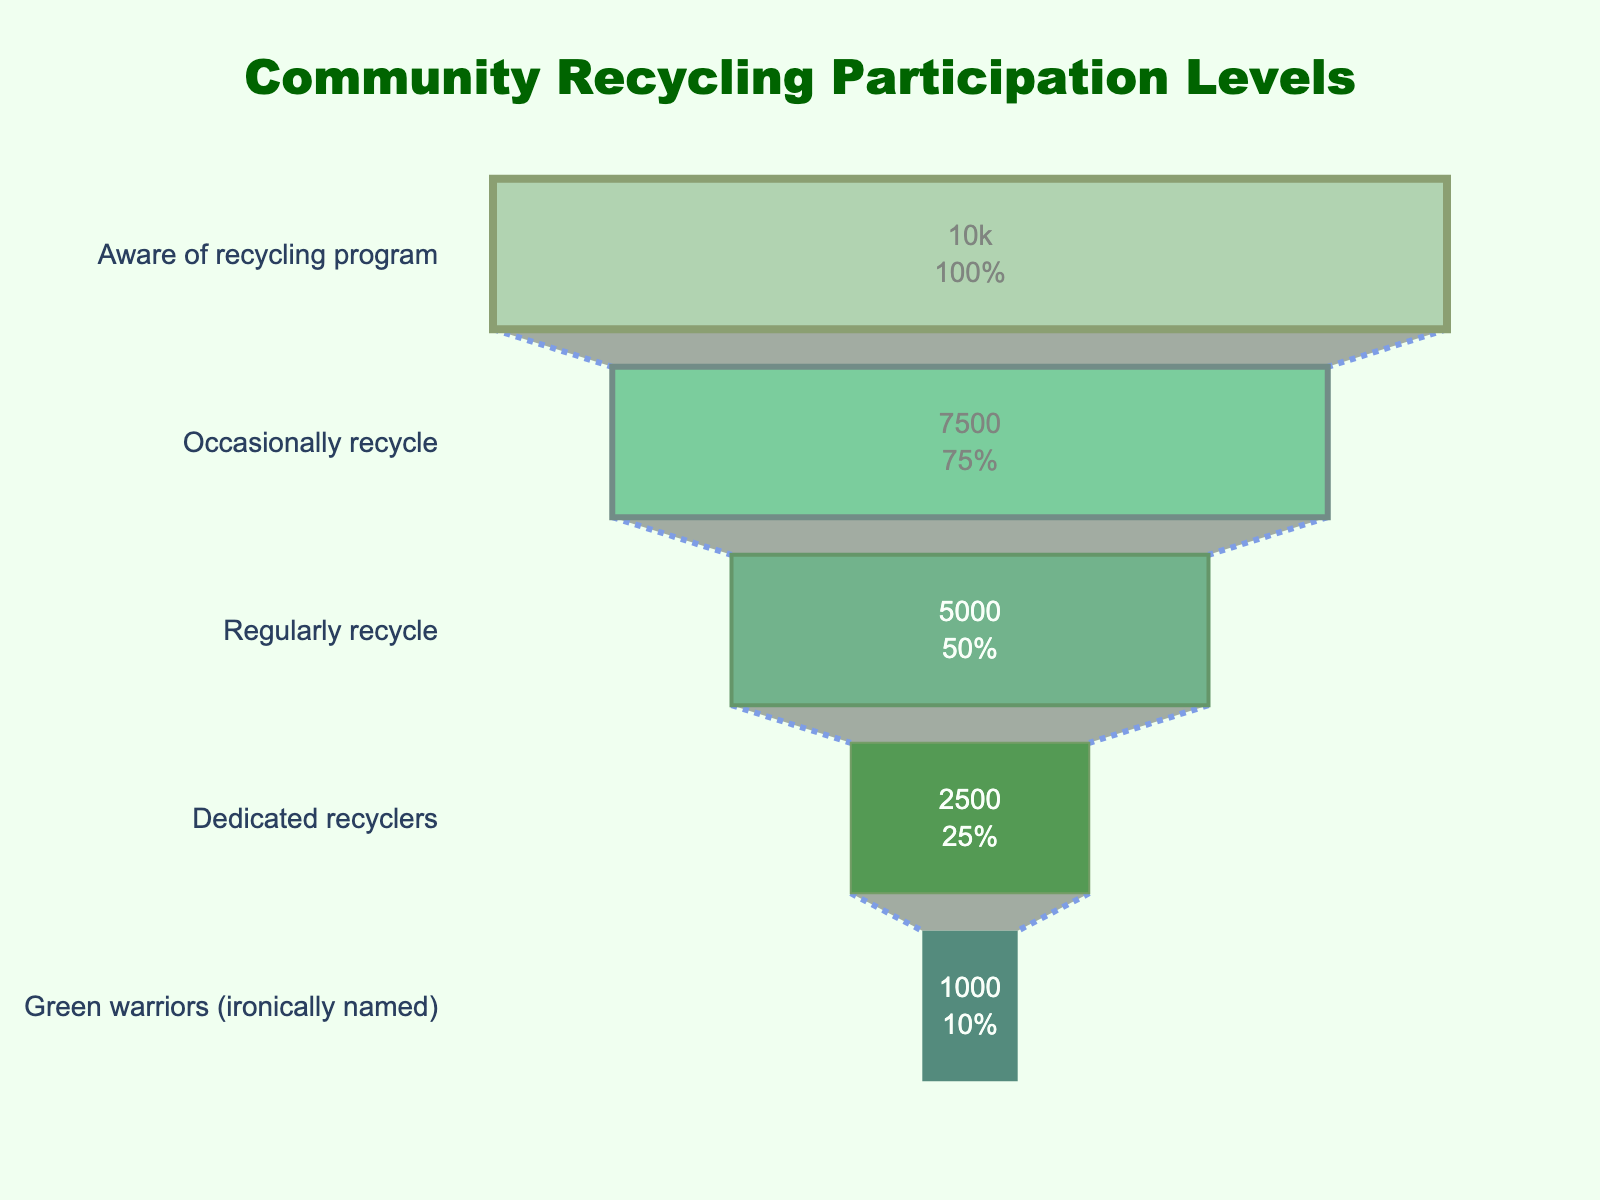What's the title of the funnel chart? The title is usually positioned at the top of the chart. In this funnel chart, it states "Community Recycling Participation Levels."
Answer: Community Recycling Participation Levels How many participants are categorized as "Dedicated recyclers"? The "Dedicated recyclers" stage on the funnel indicates the number of participants, which is 2,500.
Answer: 2,500 What percentage of participants move from occasionally recycle to regularly recycle? To calculate the percentage conversion, divide the number of regular recyclers (5,000) by the number of occasional recyclers (7,500) and multiply by 100. The formula is (5,000 / 7,500) * 100%.
Answer: 66.67% How many more participants are aware of the recycling program compared to being "Green warriors"? Subtract the number of "Green warriors" (1,000) from those aware of the recycling program (10,000). The difference is calculated as 10,000 - 1,000.
Answer: 9,000 Which group has the smallest number of participants? Looking at the funnel chart, the "Green warriors" stage has the smallest number of participants, which is 1,000.
Answer: "Green warriors" What is the overall drop-off rate from the beginning to the end of the funnel? To determine the overall drop-off rate, subtract the number of "Green warriors" (1,000) from those aware of the recycling program (10,000), divide by the initial number (10,000), and multiply by 100. The calculation is ((10,000 - 1,000) / 10,000) * 100%.
Answer: 90% How does the number of regular recyclers compare to those who occasionally recycle? Comparing the two stages: there are 7,500 occasional recyclers and 5,000 regular recyclers. Regular recyclers are fewer in number.
Answer: Fewer What does the annotation at the bottom of the chart say? The annotation at the bottom of the funnel chart states: "Ironically, the 'Green warriors' are the smallest group."
Answer: "Ironically, the 'Green warriors' are the smallest group." What is the color scheme used in the funnel chart? The funnel chart uses varying shades of green for each stage, starting from lighter green at the top to darker as it moves down. Lighter greens represent larger groups, and darker greens represent smaller groups.
Answer: Shades of green How is the percentage of participants who skip any stage calculated from the chart? To calculate the dropout rate from one stage to the next, subtract the number of participants in the later stage from the earlier stage, divide by the number in the earlier stage, and multiply by 100. For example, the dropout from aware to occasionally recycle: ((10,000 - 7,500) / 10,000) * 100%.
Answer: Calculation steps provided 